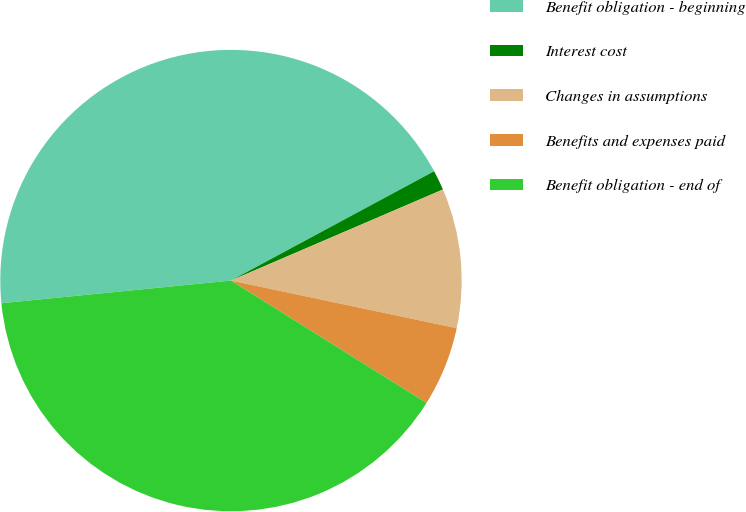<chart> <loc_0><loc_0><loc_500><loc_500><pie_chart><fcel>Benefit obligation - beginning<fcel>Interest cost<fcel>Changes in assumptions<fcel>Benefits and expenses paid<fcel>Benefit obligation - end of<nl><fcel>43.71%<fcel>1.4%<fcel>9.77%<fcel>5.59%<fcel>39.53%<nl></chart> 